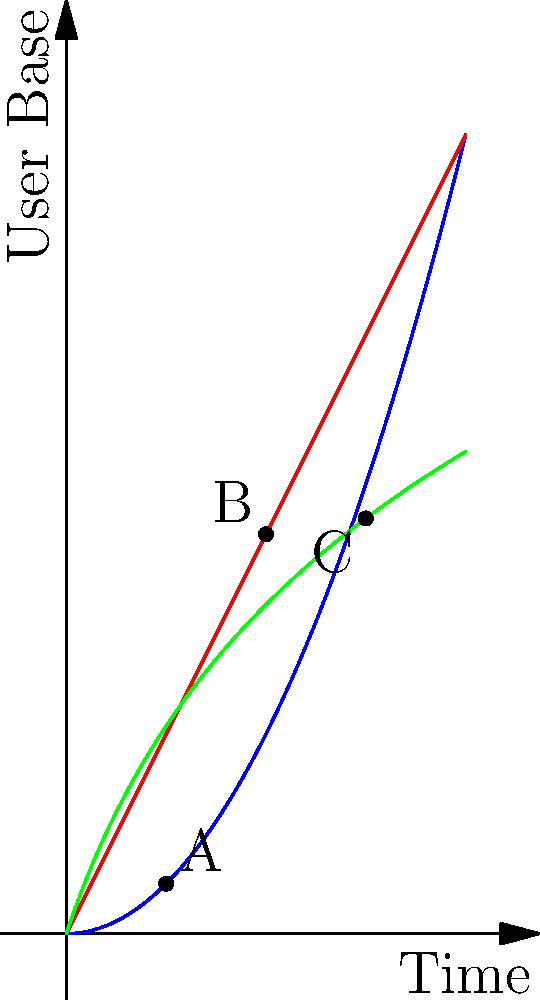In the graph, three coding practices are represented by different curves showing their impact on user base growth over time. Which coding practice (A, B, or C) best aligns with the principle of prioritizing software accessibility for a wider range of users, including those with disabilities? To determine which coding practice best aligns with prioritizing software accessibility, we need to analyze each curve:

1. Curve A (blue, labeled "Standard Code"):
   - Follows a quadratic growth pattern ($f(x) = 0.5x^2$)
   - Slow initial growth, accelerating over time
   - Not ideal for accessibility as it takes longer to reach a wider user base

2. Curve B (red, labeled "Optimized Code"):
   - Follows a linear growth pattern ($f(x) = 2x$)
   - Consistent growth rate, faster than A initially
   - Better than A, but still not prioritizing accessibility for all users

3. Curve C (green, labeled "Accessible Code"):
   - Follows a logarithmic growth pattern ($f(x) = 3\log(x+1)$)
   - Rapid initial growth, then slowing down
   - Reaches a wider user base quickly, indicating early adoption by diverse users

The logarithmic growth of Curve C suggests that it prioritizes accessibility from the beginning, allowing for rapid adoption by a diverse user base, including those with disabilities. This aligns best with the principle of prioritizing software accessibility for a wider range of users.
Answer: C 